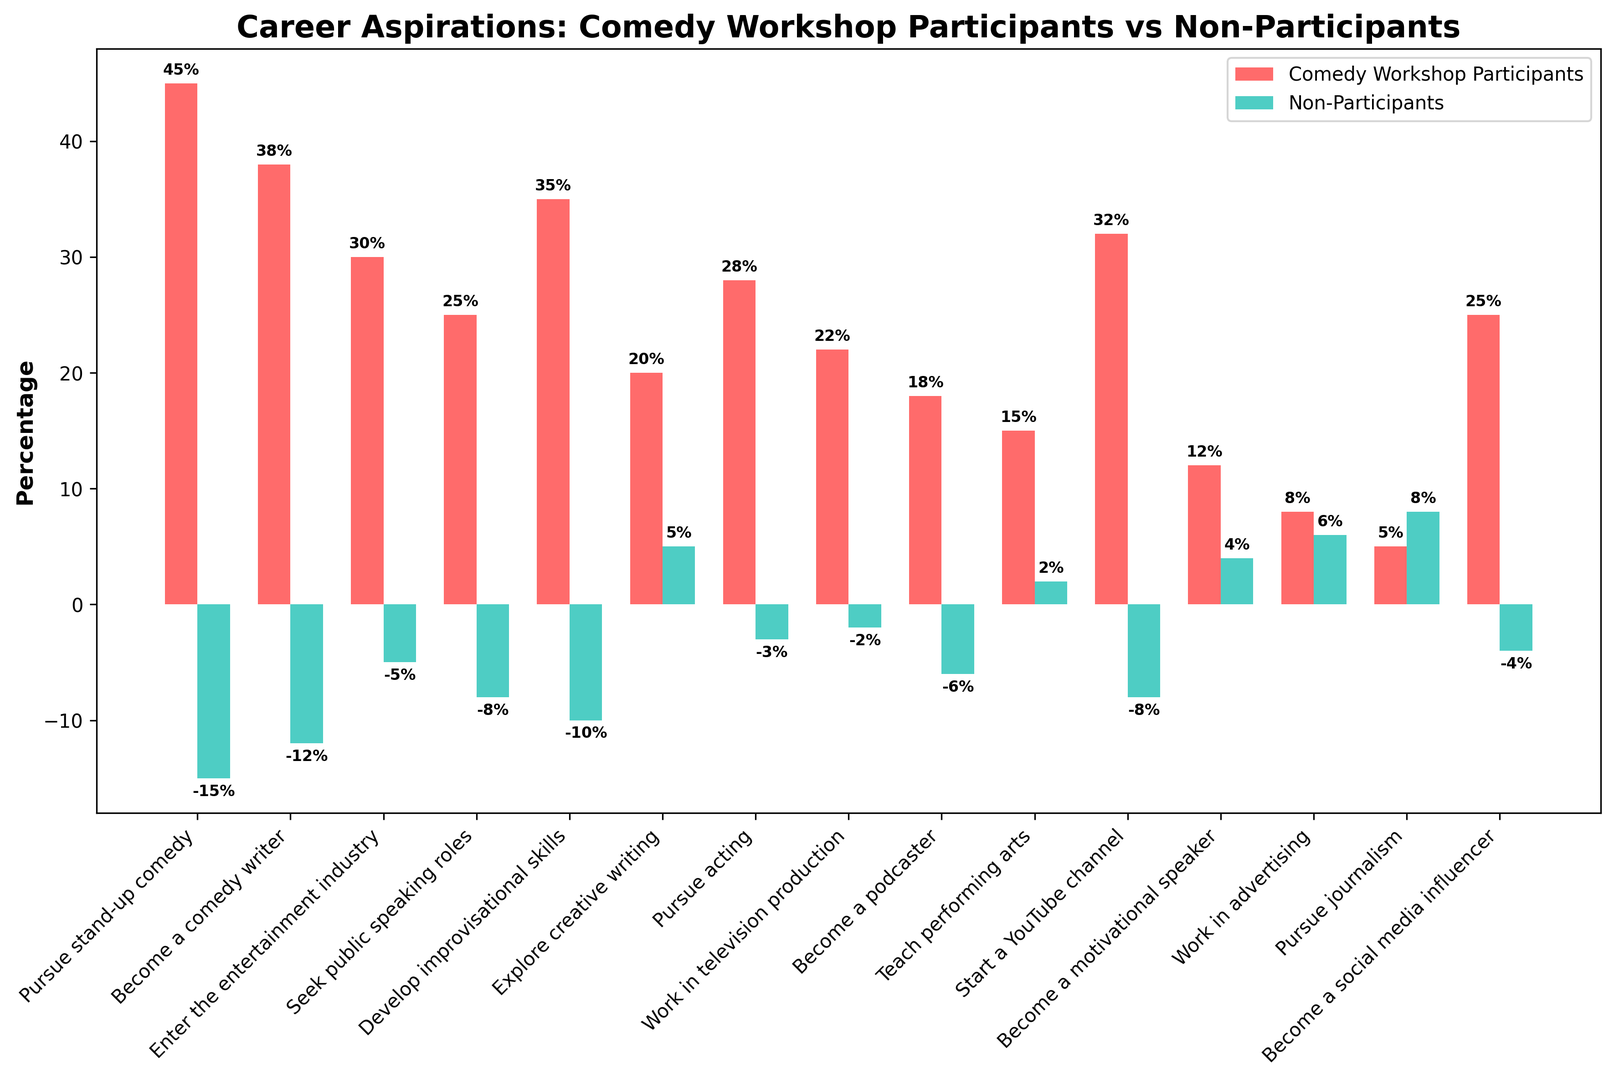Which career aspiration has the biggest difference in percentage between Comedy Workshop Participants and Non-Participants? To find this, look at the absolute difference in the values for each career aspiration between the two groups. The biggest difference is for "Pursue stand-up comedy" with a difference of \(45 - (-15) = 60\).
Answer: Pursue stand-up comedy Which career aspiration has a positive percentage for Non-Participants but a negative percentage for Comedy Workshop Participants? Look at the bars for Non-Participants to see which career aspirations have positive percentages, then check if any of those bars have a negative percentage for Comedy Workshop Participants. This occurs for "Explore creative writing" with values 5 for Non-Participants and -20 for Comedy Workshop Participants.
Answer: Explore creative writing Are there any career aspirations where Comedy Workshop Participants and Non-Participants have the same percentage? Scan the heights of the bars to see if any pair of bars for a career aspiration have the same value. There are no career aspirations where the values are the same among the groups.
Answer: No Which group has a higher percentage for seeking public speaking roles? Compare the red bar (Comedy Workshop Participants) and the green bar (Non-Participants) for "Seek public speaking roles". The red bar has a higher value (25) compared to the green bar (-8).
Answer: Comedy Workshop Participants What's the total percentage of participants aspiring to work in television production and pursue journalism for both groups combined? Sum the percentages of "Work in television production" and "Pursue journalism" for both groups. For Workshop Participants: \(22 + 5 = 27\). For Non-Participants: \(-2 + 8 = 6\). The combined total is \(27 + 6 = 33\).
Answer: 33 What proportion of Comedy Workshop Participants aspire to become comedy writers compared to those who want to start a YouTube channel? The percentage for "Become a comedy writer" is 38, and for "Start a YouTube channel" it's 32. The ratio is \( \frac{38}{32} = 1.19\).
Answer: 1.19 Is teaching performing arts more popular among Non-Participants compared to participating in comedy workshops? Check the percentage values for "Teach performing arts". Comedy Workshop Participants have 15, Non-Participants have 2. Teaching performing arts is more popular among those in workshops.
Answer: No Which career aspiration has a similar percentage for both groups but with different signs (one positive and the other negative)? Look for career aspirations where one group has a positive value and the other has a corresponding negative value, and the magnitude of the difference is small. "Pursue acting" has values 28 (Comedy Workshop Participants) and -3 (Non-Participants). However, for closer small magnitude difference, "Seek public speaking roles" with 25 and -8 would be of interest.
Answer: Seek public speaking roles 